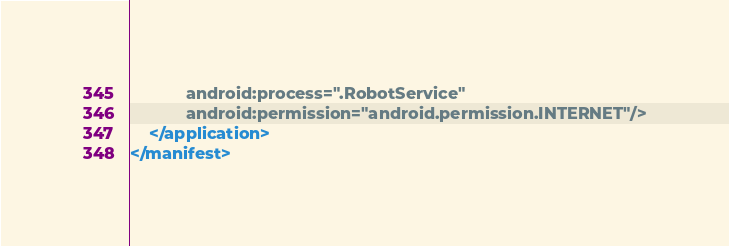Convert code to text. <code><loc_0><loc_0><loc_500><loc_500><_XML_>            android:process=".RobotService"
            android:permission="android.permission.INTERNET"/>
    </application>
</manifest></code> 